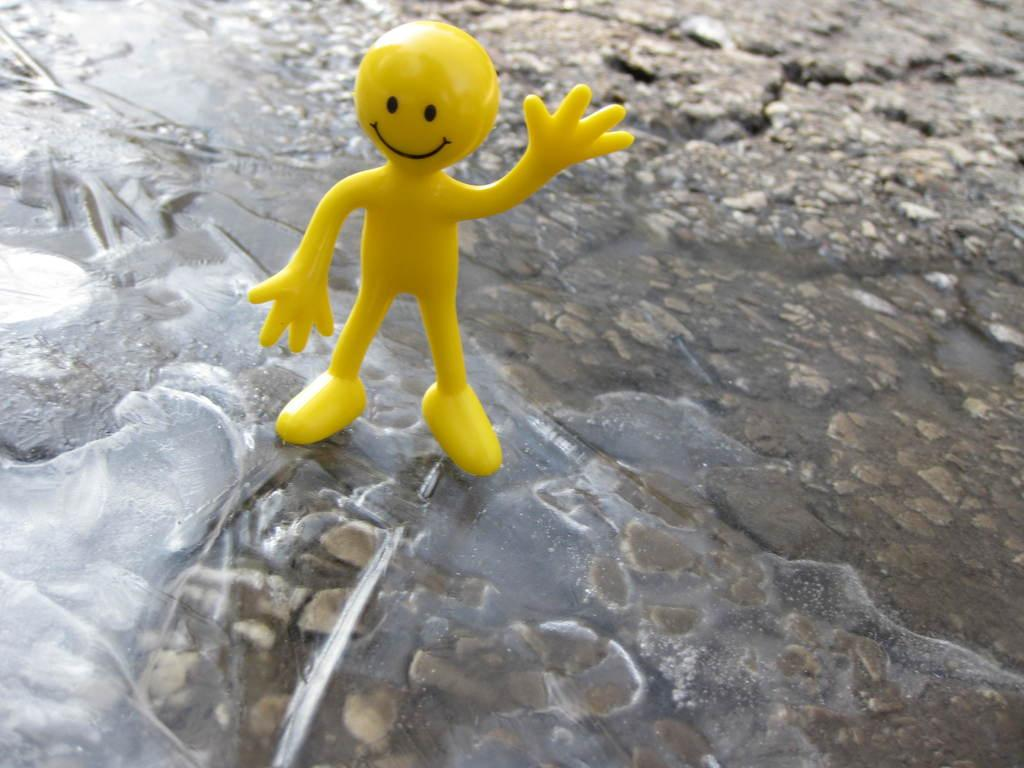What color is the toy in the image? The toy in the image is yellow. Where is the yellow toy located? The toy is on a rock. What can be seen at the bottom of the image? There is water visible at the bottom of the image. Reasoning: Let' Let's think step by step in order to produce the conversation. We start by identifying the main subject in the image, which is the yellow toy. Then, we describe its location, which is on a rock. Finally, we mention the water visible at the bottom of the image. Each question is designed to elicit a specific detail about the image that is known from the provided facts. Absurd Question/Answer: What type of coil is used to hold the toy in the image? There is no coil present in the image; the toy is simply resting on a rock. 